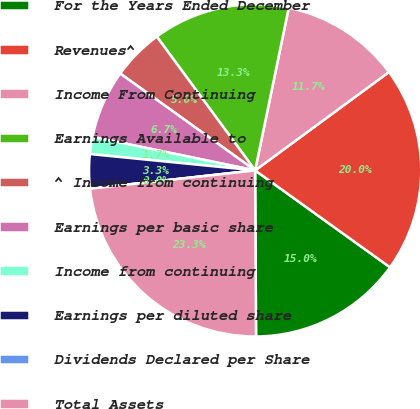<chart> <loc_0><loc_0><loc_500><loc_500><pie_chart><fcel>For the Years Ended December<fcel>Revenues^<fcel>Income From Continuing<fcel>Earnings Available to<fcel>^ Income from continuing<fcel>Earnings per basic share<fcel>Income from continuing<fcel>Earnings per diluted share<fcel>Dividends Declared per Share<fcel>Total Assets<nl><fcel>15.0%<fcel>20.0%<fcel>11.67%<fcel>13.33%<fcel>5.0%<fcel>6.67%<fcel>1.67%<fcel>3.33%<fcel>0.0%<fcel>23.33%<nl></chart> 